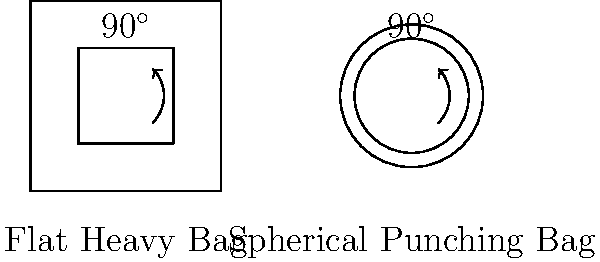As a former boxer who has trained with various equipment, consider the difference in angular measurements between a flat heavy bag and a spherical punching bag. If you draw two lines from the center of each bag to its surface, creating a 90° angle on both, how would the distance between the endpoints of these lines compare on the flat bag versus the spherical bag? Let's approach this step-by-step:

1) On a flat heavy bag:
   - The surface is Euclidean (flat).
   - A 90° angle drawn from the center will create a quarter of a circle.
   - The distance between the endpoints will be proportional to the radius of the circle.

2) On a spherical punching bag:
   - The surface is non-Euclidean (curved).
   - A 90° angle drawn from the center will also create a quarter of a circle, but on a curved surface.
   - The distance between the endpoints will be shorter than on the flat surface.

3) The reason for this difference:
   - On a sphere, the sum of angles in a triangle is greater than 180°.
   - This means that for the same central angle, the arc length on a sphere is shorter than on a flat surface.

4) Mathematically:
   - On a flat surface, the arc length for a 90° angle is $\frac{\pi r}{2}$, where $r$ is the radius.
   - On a sphere, the arc length for a 90° angle is $\frac{\pi R}{2}$, where $R$ is the radius of the sphere.
   - However, the straight-line distance between the endpoints on a sphere is the chord length, which is $R\sqrt{2}$.
   - This chord length is always less than the arc length on the flat surface for the same angle.

5) In boxing terms:
   - This means that punches thrown at the same angle will travel a shorter distance on the surface of a spherical bag compared to a flat bag.
   - This could affect timing and distance perception when training on different types of bags.
Answer: The distance between endpoints is shorter on the spherical bag than on the flat bag. 